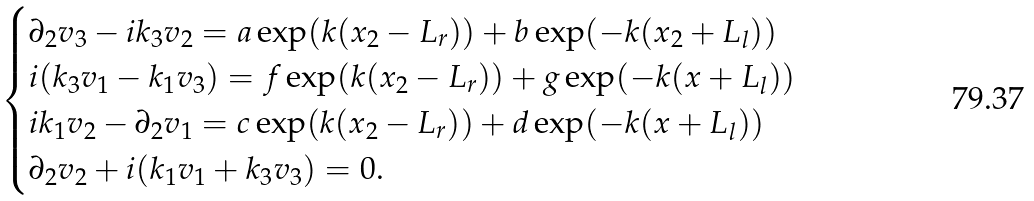Convert formula to latex. <formula><loc_0><loc_0><loc_500><loc_500>\begin{cases} \partial _ { 2 } v _ { 3 } - i k _ { 3 } v _ { 2 } = a \exp ( k ( x _ { 2 } - L _ { r } ) ) + b \exp ( - k ( x _ { 2 } + L _ { l } ) ) \\ i ( k _ { 3 } v _ { 1 } - k _ { 1 } v _ { 3 } ) = f \exp ( k ( x _ { 2 } - L _ { r } ) ) + g \exp ( - k ( x + L _ { l } ) ) \\ i k _ { 1 } v _ { 2 } - \partial _ { 2 } v _ { 1 } = c \exp ( k ( x _ { 2 } - L _ { r } ) ) + d \exp ( - k ( x + L _ { l } ) ) \\ \partial _ { 2 } v _ { 2 } + i ( k _ { 1 } v _ { 1 } + k _ { 3 } v _ { 3 } ) = 0 . \\ \end{cases}</formula> 